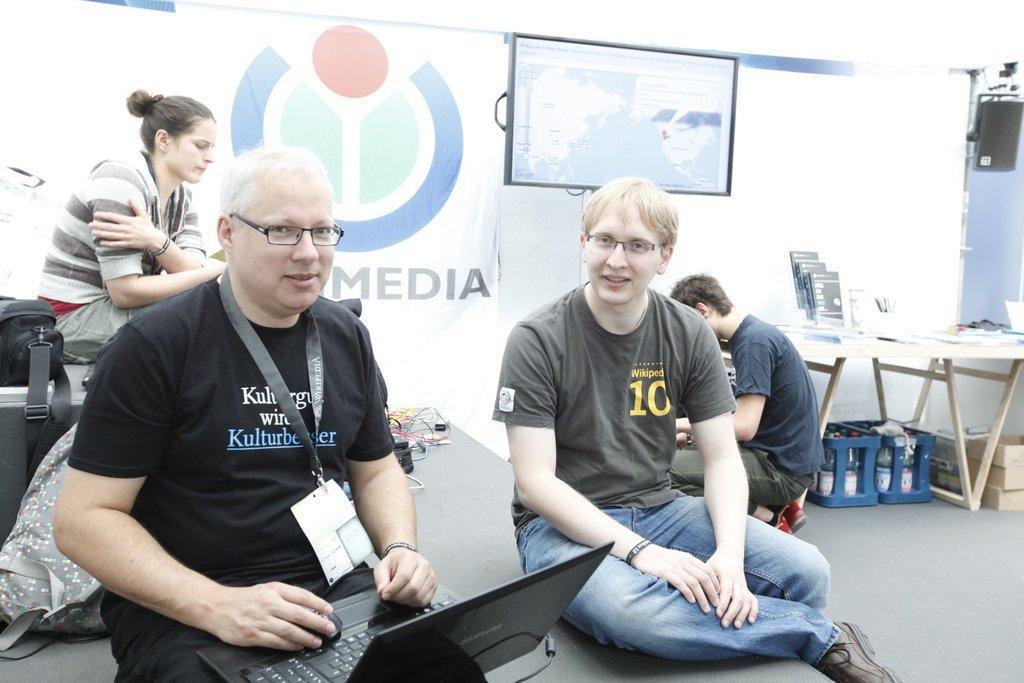Describe this image in one or two sentences. In the center of the image we can see two people are sitting on the stage and a man is wearing id card and holding a laptop, mouse. On the left side of the image we can see the bags and a lady is sitting. In the background of the image we can see the banner, wall, screen, cables, table, container, light, boxes and a man is sitting on his knees. On the table we can see the books, pens and some other objects. In the bottom right corner we can see the floor. 